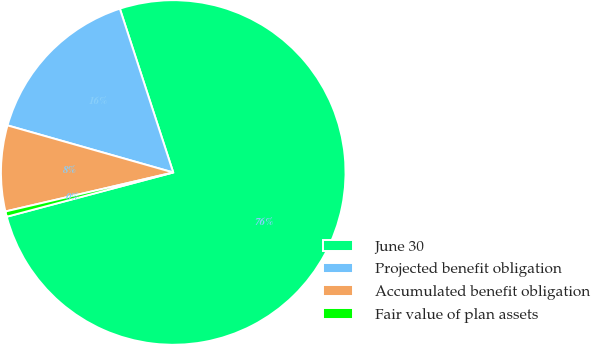Convert chart to OTSL. <chart><loc_0><loc_0><loc_500><loc_500><pie_chart><fcel>June 30<fcel>Projected benefit obligation<fcel>Accumulated benefit obligation<fcel>Fair value of plan assets<nl><fcel>75.88%<fcel>15.58%<fcel>8.04%<fcel>0.5%<nl></chart> 